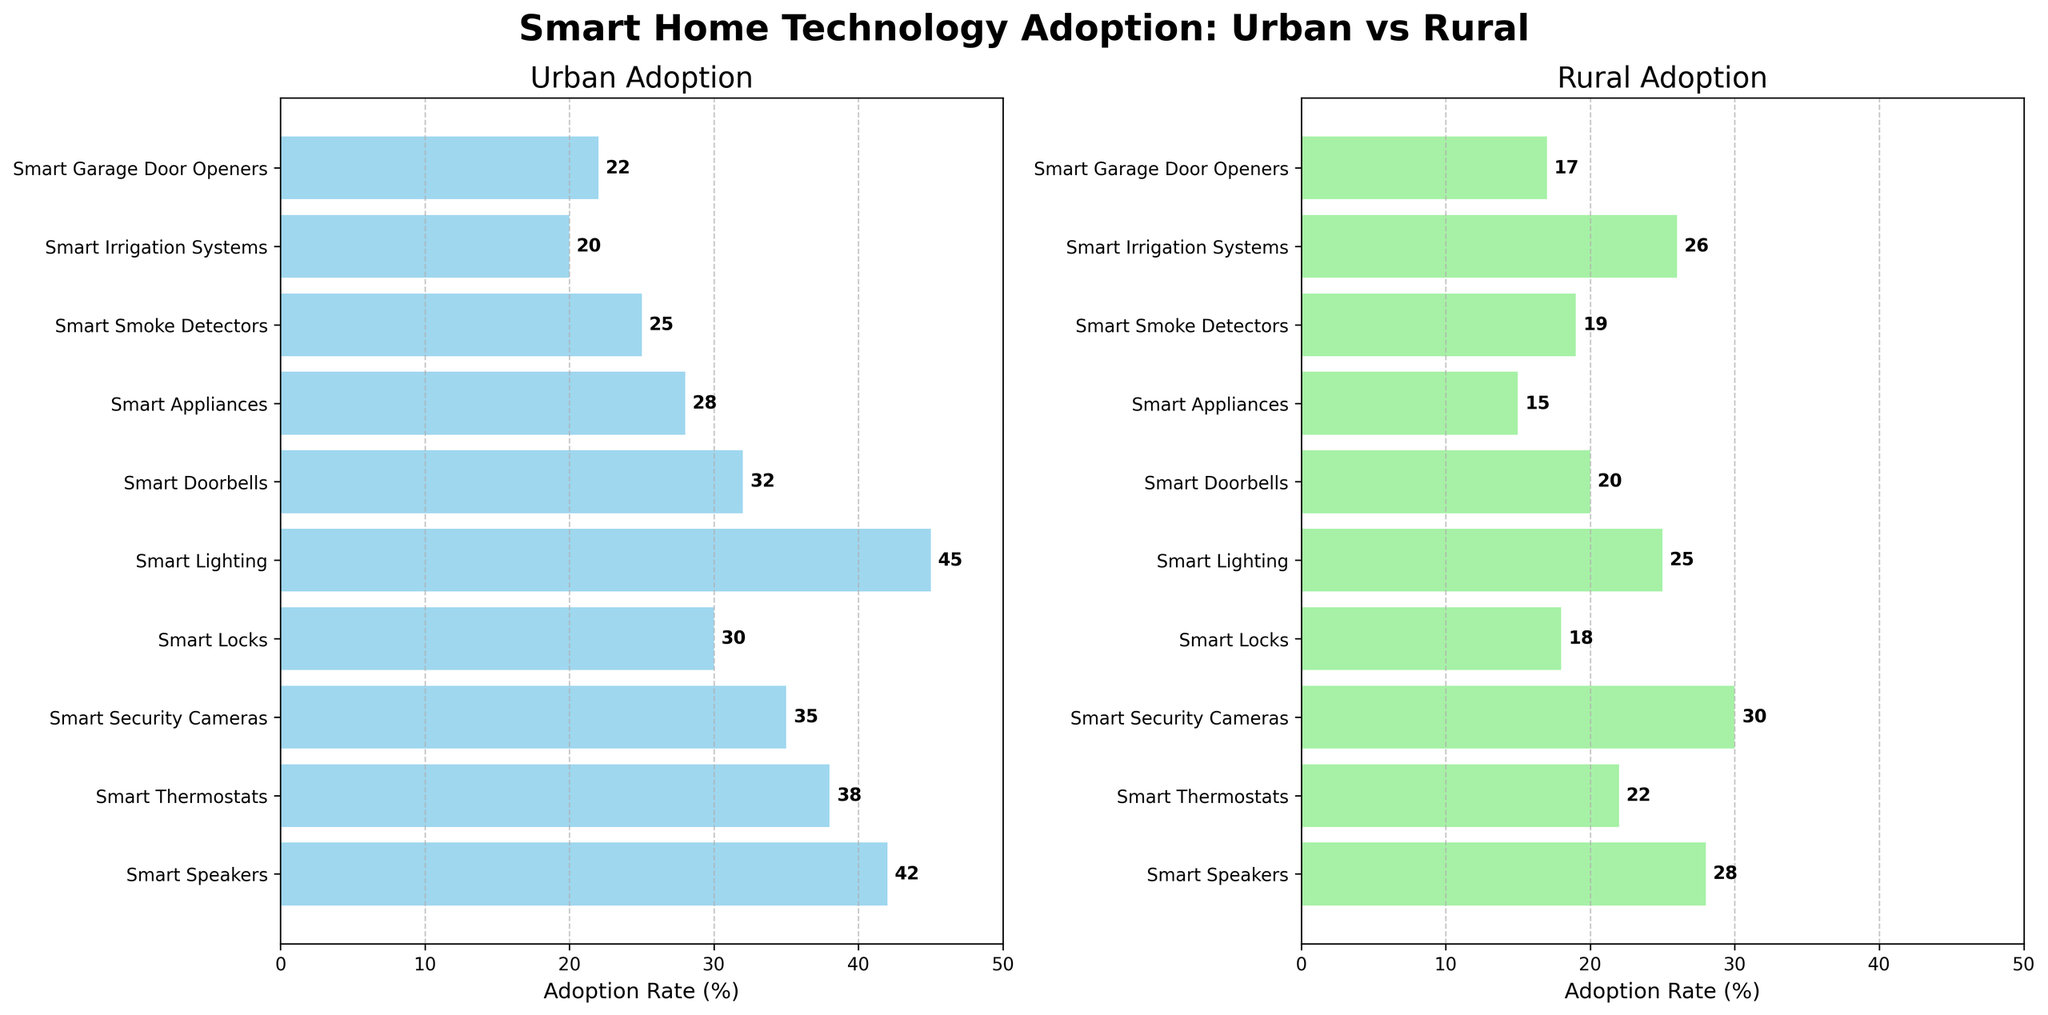What is the title of the figure? The title of the figure is prominently displayed at the top. It reads "Smart Home Technology Adoption: Urban vs Rural"
Answer: Smart Home Technology Adoption: Urban vs Rural How many smart home technologies show higher adoption rates in urban areas compared to rural areas? Count the number of technologies where the urban adoption percentage is higher than the rural adoption percentage. There are 8 such technologies.
Answer: 8 Which technology has the highest adoption rate in urban areas? By looking at the bars in the urban adoption subplot, the tallest bar corresponds to Smart Lighting with a 45% adoption rate.
Answer: Smart Lighting What is the difference in adoption rates for Smart Thermostats between urban and rural areas? Find the adoption rates for Smart Thermostats in both subplots: 38% for urban and 22% for rural. The difference is 38 - 22 = 16%.
Answer: 16% Are there any technologies with equal adoption rates in both urban and rural areas? Compare the bars in the two subplots. None of the bars are equal in length, suggesting that there are no technologies with equal adoption rates in both areas.
Answer: None What is the average adoption rate of all technologies in rural areas? Add up the adoption rates of all technologies in rural areas and divide by the number of technologies: (28+22+30+18+25+20+15+19+26+17) / 10 = 220 / 10 = 22%.
Answer: 22% Which technology has the highest adoption rate in rural areas? In the rural adoption subplot, the tallest bar corresponds to Smart Security Cameras with a 30% adoption rate.
Answer: Smart Security Cameras Which technology has the largest difference in adoption rates between urban and rural areas? Calculate the differences for each technology and find the maximum: 
- Smart Speakers: 42 - 28 = 14%
- Smart Thermostats: 38 - 22 = 16%
- Smart Security Cameras: 35 - 30 = 5%
- Smart Locks: 30 - 18 = 12%
- Smart Lighting: 45 - 25 = 20%
- Smart Doorbells: 32 - 20 = 12%
- Smart Appliances: 28 - 15 = 13%
- Smart Smoke Detectors: 25 - 19 = 6%
- Smart Irrigation Systems: 20 - 26 = -6%
- Smart Garage Door Openers: 22 - 17 = 5%
The largest difference is for Smart Lighting with 20%.
Answer: Smart Lighting What is the combined adoption rate of Smart Doorbells and Smart Garage Door Openers in urban areas? Add the adoption rates of Smart Doorbells and Smart Garage Door Openers in urban areas: 32% + 22% = 54%.
Answer: 54% For which technology is the adoption rate higher in rural areas than in urban areas? Look for bars that are taller in the rural adoption subplot than in the urban adoption subplot. The only such technology is Smart Irrigation Systems with rural at 26% and urban at 20%.
Answer: Smart Irrigation Systems 